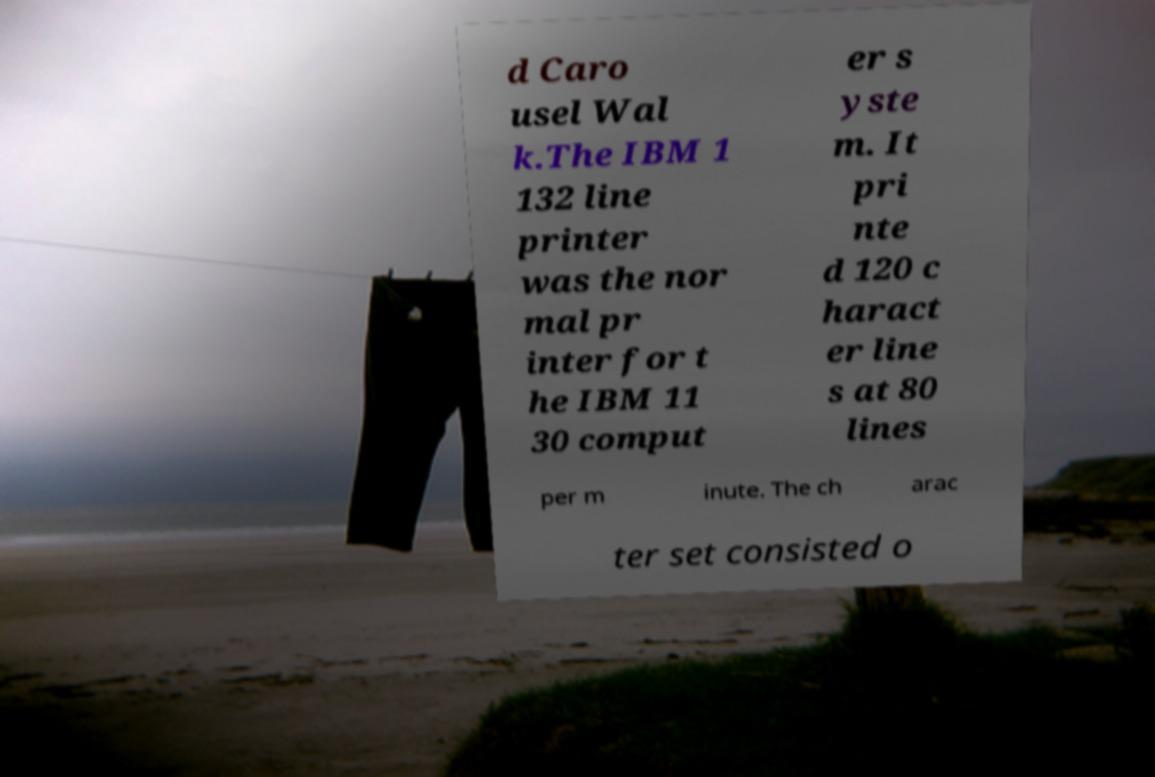Can you accurately transcribe the text from the provided image for me? d Caro usel Wal k.The IBM 1 132 line printer was the nor mal pr inter for t he IBM 11 30 comput er s yste m. It pri nte d 120 c haract er line s at 80 lines per m inute. The ch arac ter set consisted o 